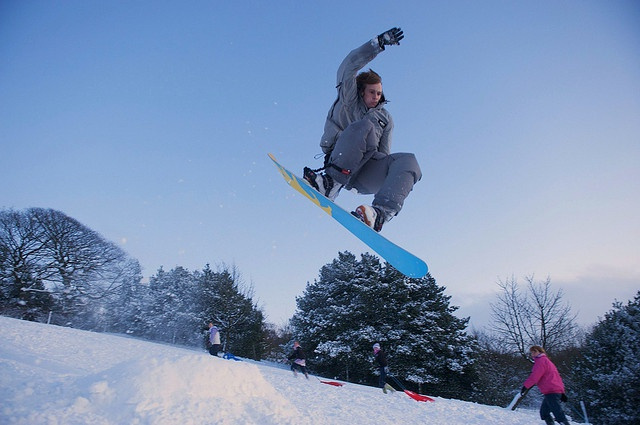Describe the objects in this image and their specific colors. I can see people in blue, gray, navy, darkblue, and darkgray tones, snowboard in blue, gray, tan, and darkgray tones, people in blue, black, purple, and navy tones, people in blue, black, gray, and navy tones, and people in blue, black, navy, and gray tones in this image. 